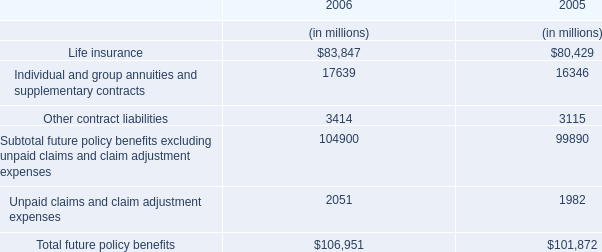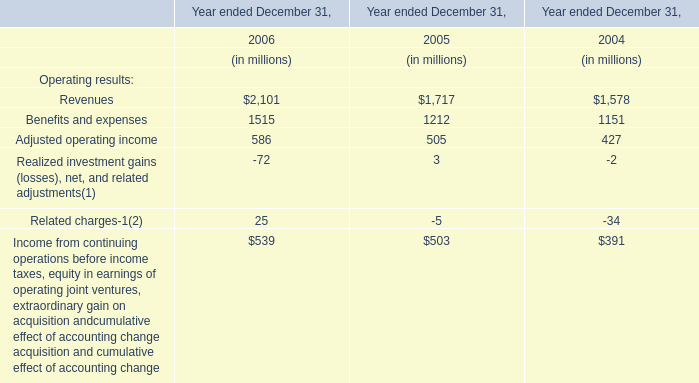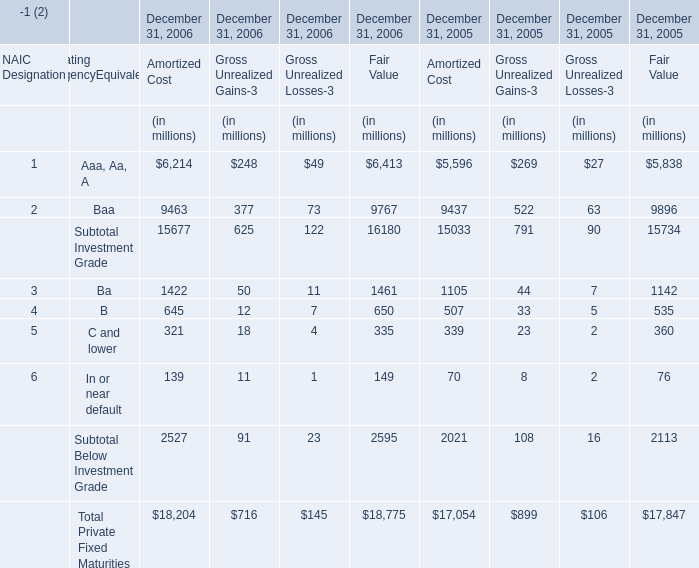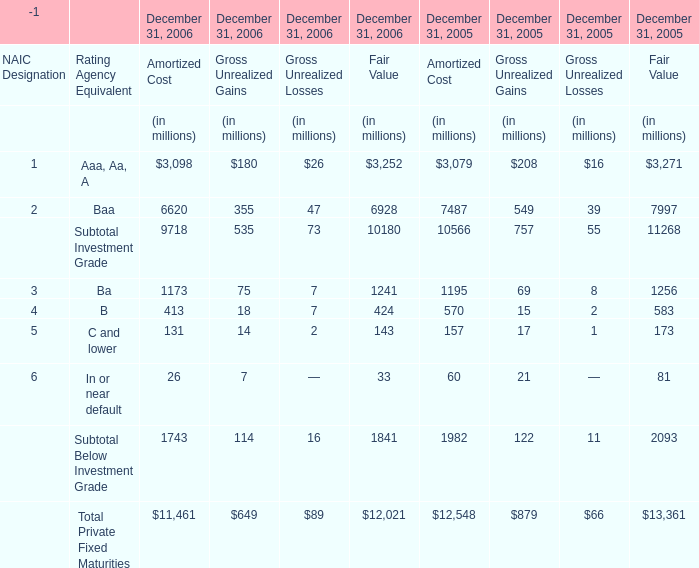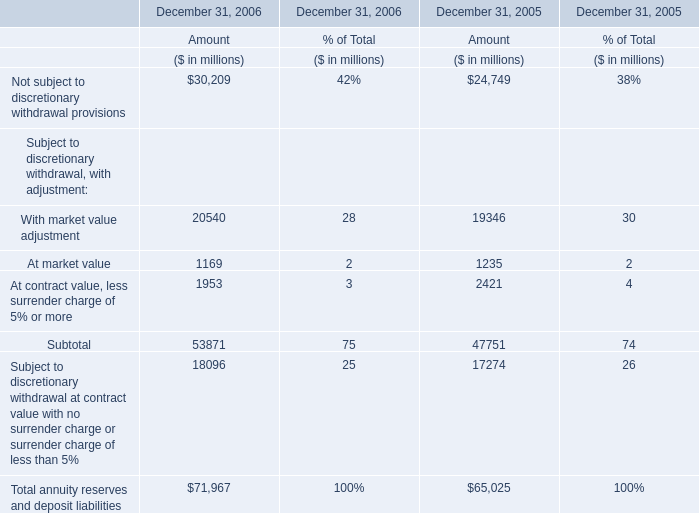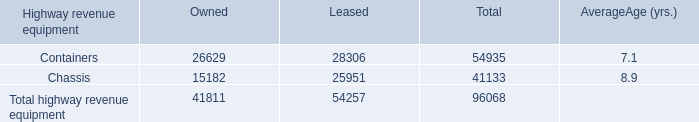how much of the 2015 capital plan is for ptc expenditures? 
Computations: (450 / (4.3 * 1000))
Answer: 0.10465. 